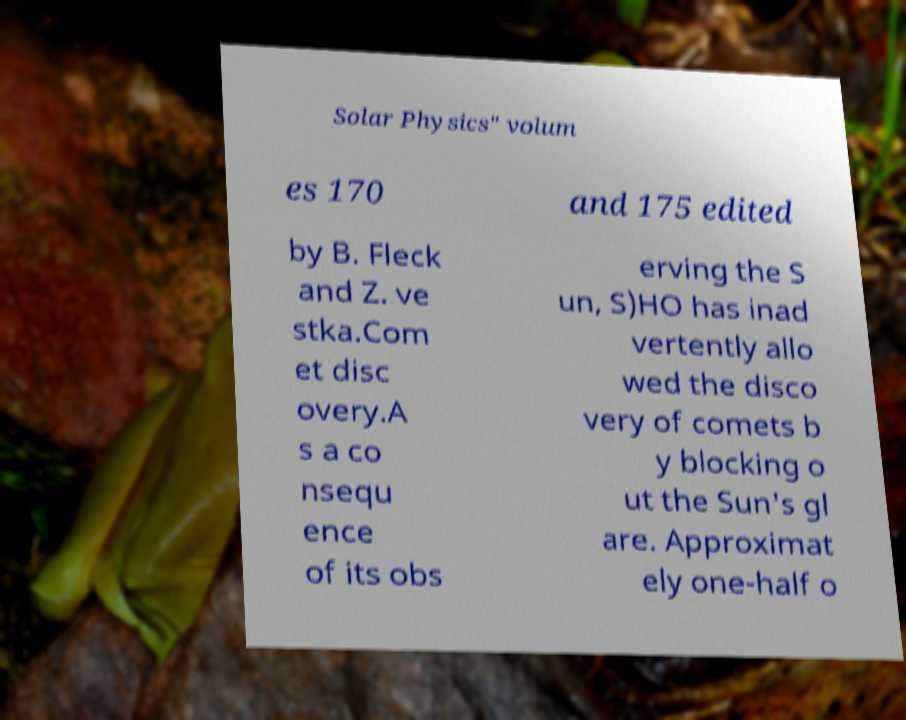Could you extract and type out the text from this image? Solar Physics" volum es 170 and 175 edited by B. Fleck and Z. ve stka.Com et disc overy.A s a co nsequ ence of its obs erving the S un, S)HO has inad vertently allo wed the disco very of comets b y blocking o ut the Sun's gl are. Approximat ely one-half o 